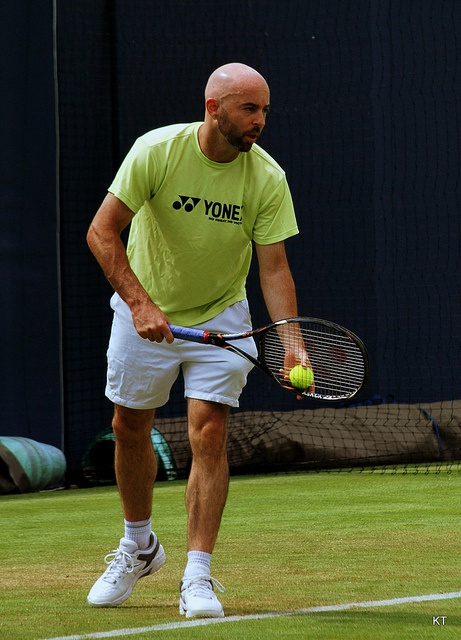Describe the objects in this image and their specific colors. I can see people in black, olive, and maroon tones, tennis racket in black, gray, and darkgray tones, and sports ball in black, khaki, and olive tones in this image. 